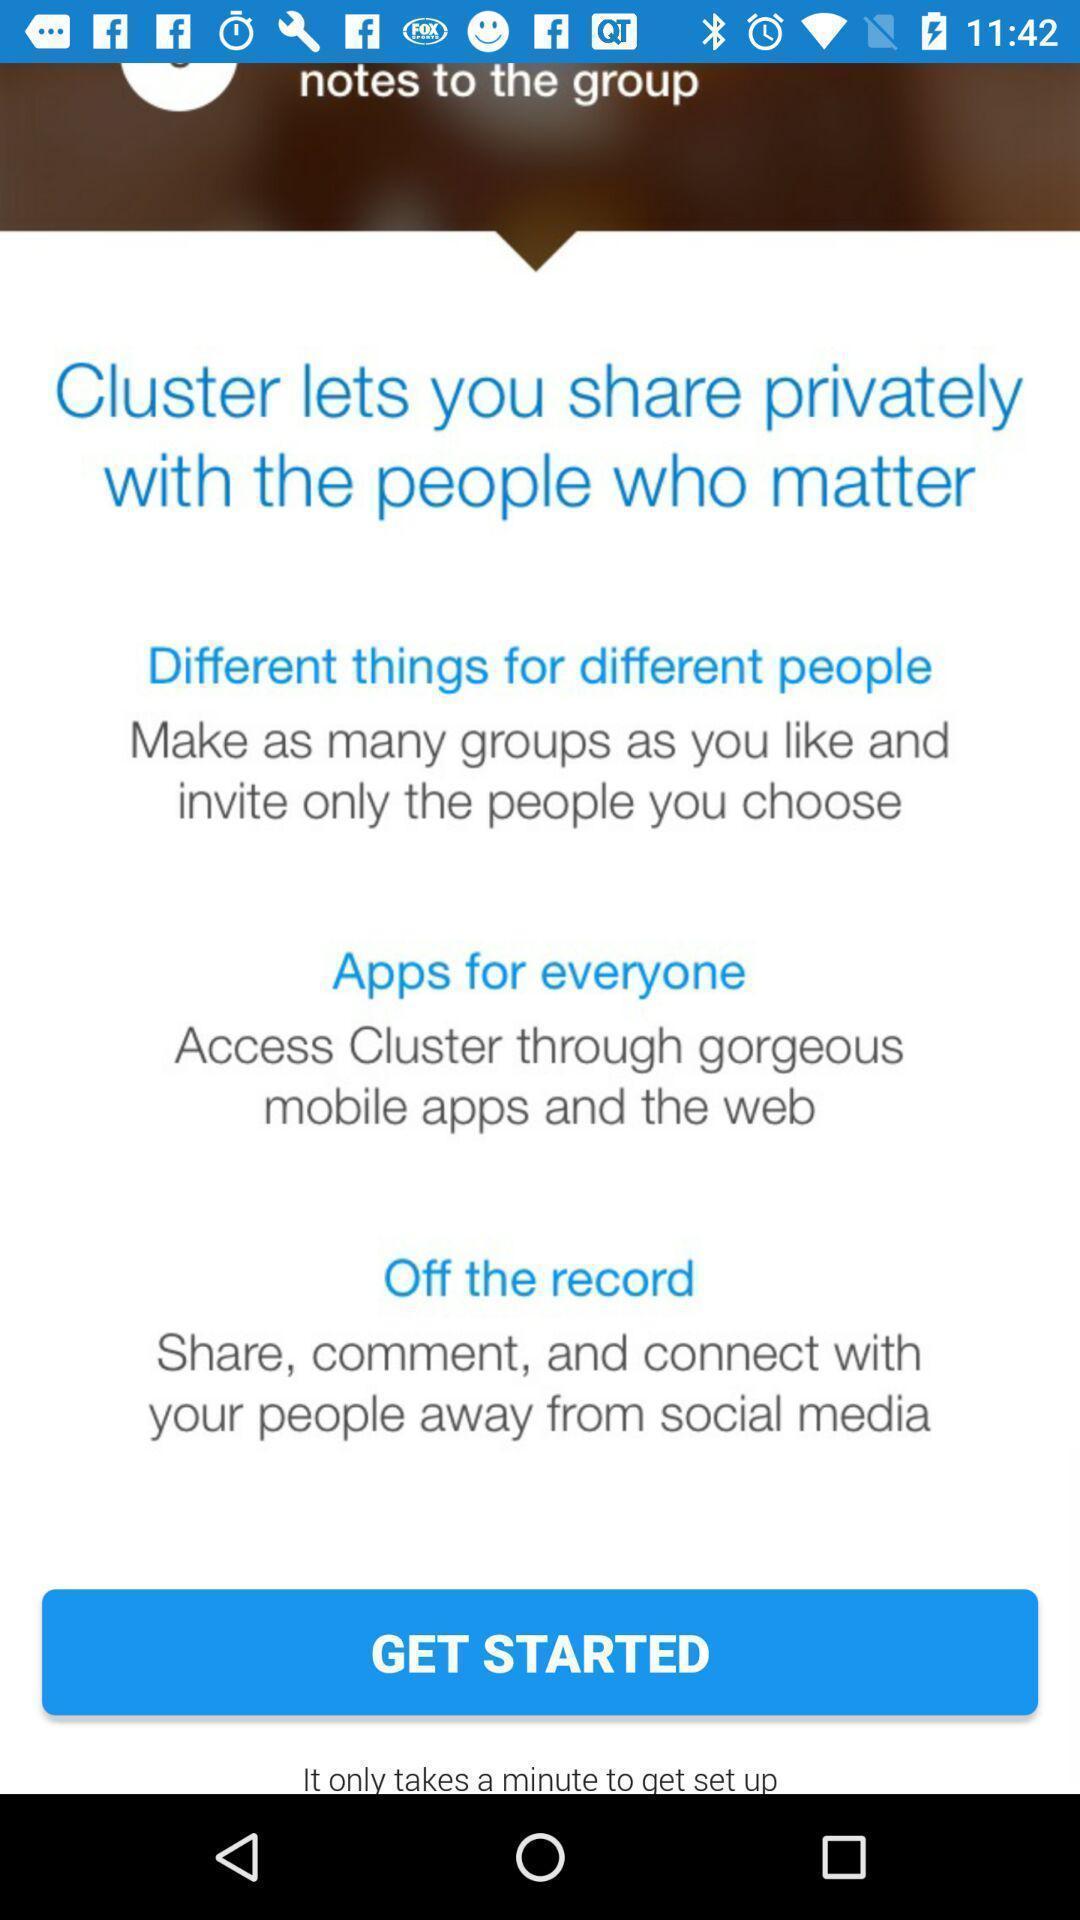Summarize the main components in this picture. Welcome page. 